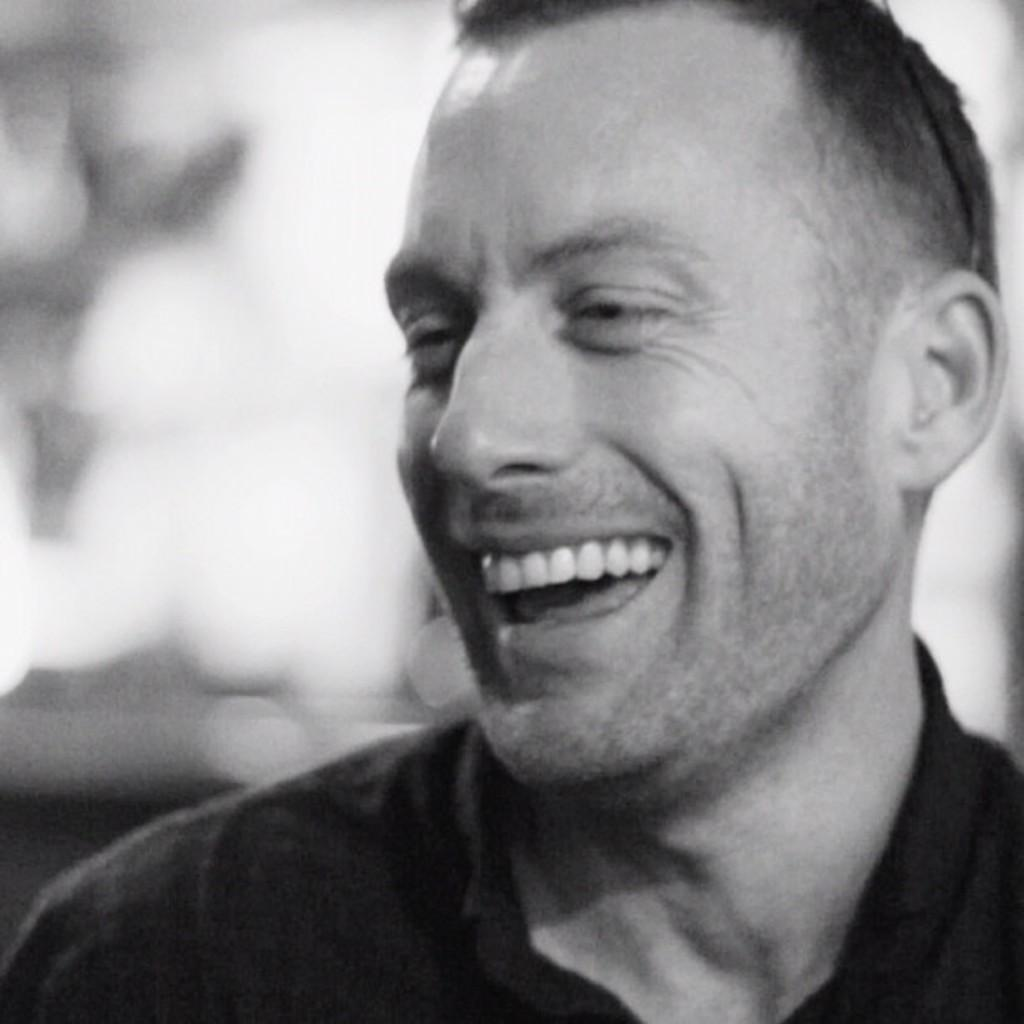What is the main subject of the image? There is a person in the image. What expression does the person have? The person is smiling. Can you describe the background of the image? The background of the image is blurry. What type of machine can be seen in the background of the image? There is no machine present in the image; the background is blurry. What material is the plastic made of in the image? There is no plastic present in the image. 